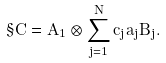Convert formula to latex. <formula><loc_0><loc_0><loc_500><loc_500>\S C = A _ { 1 } \otimes \sum _ { j = 1 } ^ { N } c _ { j } a _ { j } B _ { j } .</formula> 